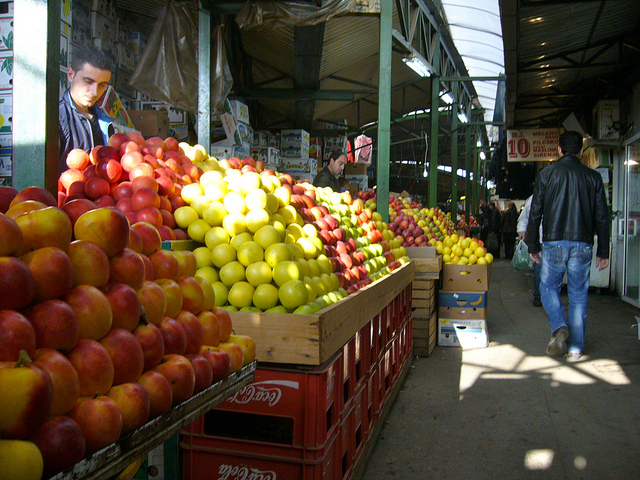<image>What is the man wearing on his wrists? I don't know what the man is wearing on his wrist. It may be a watch or nothing. What is the man wearing on his wrists? I'm not sure what the man is wearing on his wrists. It can be seen that he is wearing a watch or nothing at all. 